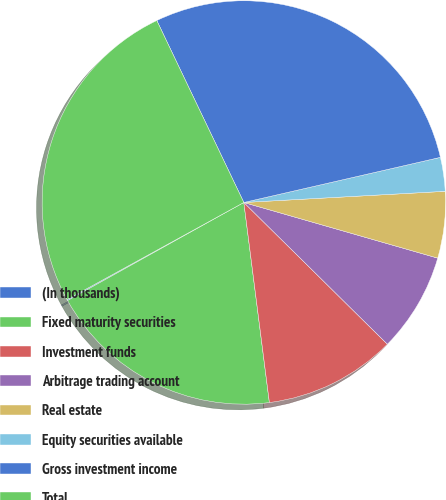<chart> <loc_0><loc_0><loc_500><loc_500><pie_chart><fcel>(In thousands)<fcel>Fixed maturity securities<fcel>Investment funds<fcel>Arbitrage trading account<fcel>Real estate<fcel>Equity securities available<fcel>Gross investment income<fcel>Total<nl><fcel>0.09%<fcel>18.94%<fcel>10.58%<fcel>7.95%<fcel>5.33%<fcel>2.71%<fcel>28.51%<fcel>25.89%<nl></chart> 